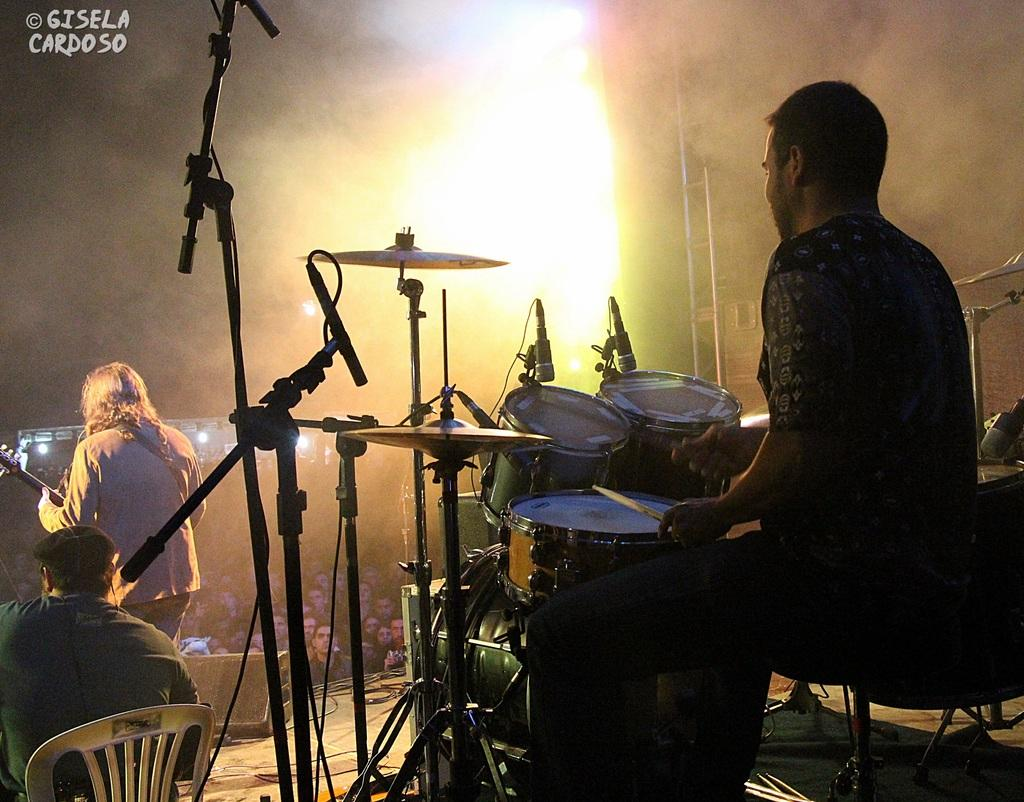Who or what can be seen in the image? There are people in the image. Where are the people located in the image? The people are on a stage. What are the people doing on the stage? The people are playing musical instruments. How many sheets of paper are being used by the people on the stage? There is no reference to sheets of paper in the image; the people are playing musical instruments. How many people are in the crowd watching the people on the stage? There is no crowd visible in the image; the people are on a stage playing musical instruments. 